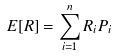Convert formula to latex. <formula><loc_0><loc_0><loc_500><loc_500>E [ R ] = \sum _ { i = 1 } ^ { n } R _ { i } P _ { i }</formula> 